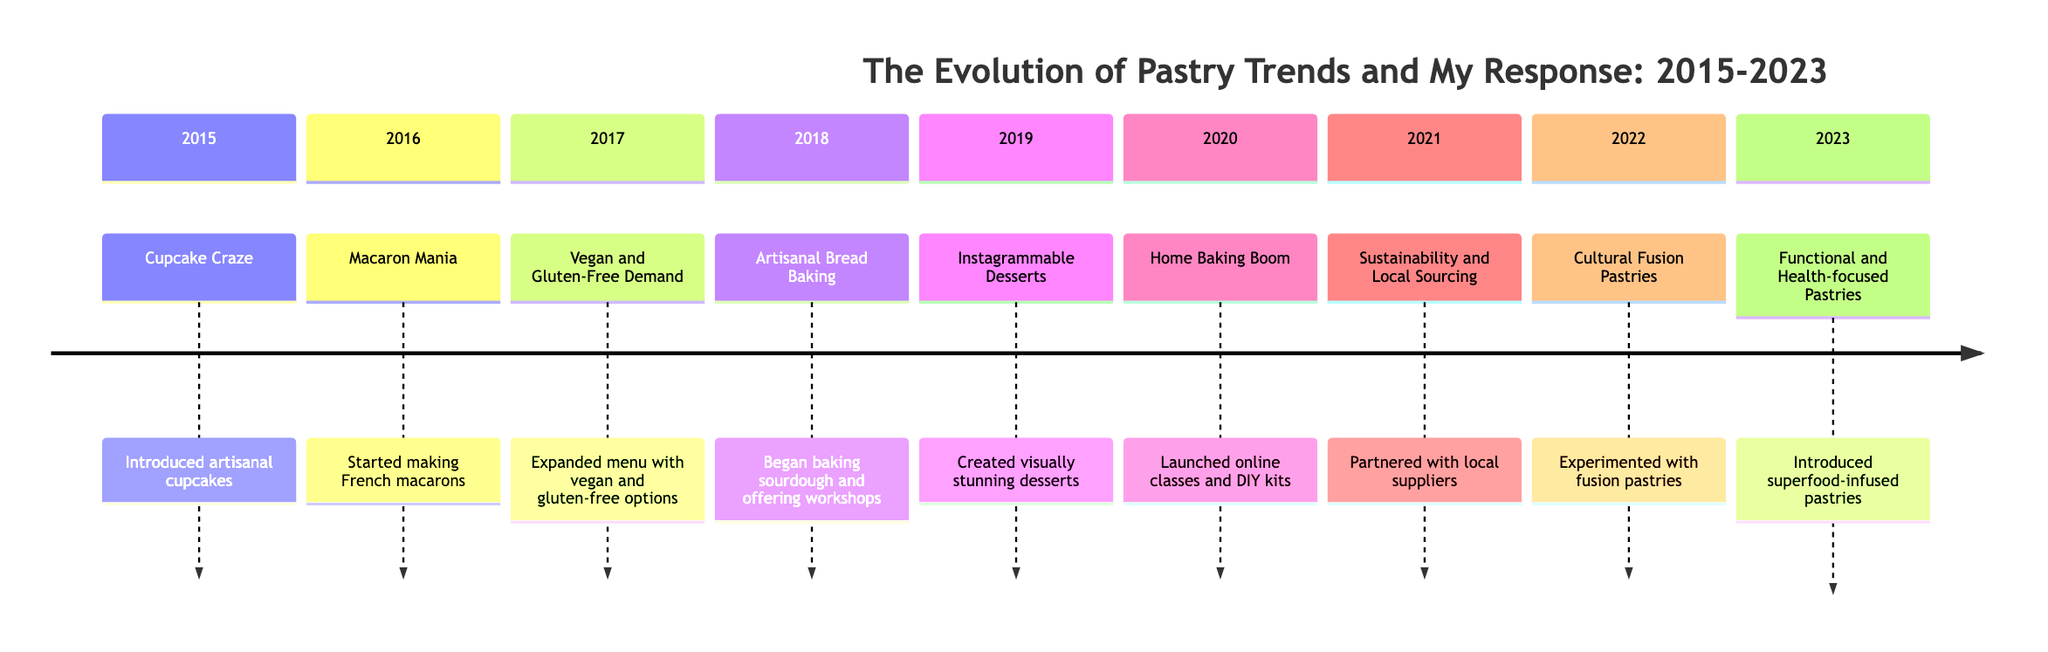What pastry trend was introduced in 2015? The diagram states that the trend introduced in 2015 is "Cupcake Craze," which can be found under the 2015 section.
Answer: Cupcake Craze What unique flavor was added to the cupcakes in 2015? The response under 2015 mentions "lavender honey" as one of the unique flavors introduced with the artisanal cupcakes during the Cupcake Craze.
Answer: Lavender honey How many trends were introduced between 2015 and 2023? By counting each year's trend listed from 2015 to 2023 in the timeline, we find a total of 9 distinct trends.
Answer: 9 What was the trend for the year 2020? The trend listed in the year 2020 is "Home Baking Boom," which is clearly stated in the corresponding section of the timeline.
Answer: Home Baking Boom Which year saw the introduction of fusion pastries? According to the timeline, the year 2022 is when "Cultural Fusion Pastries" were experimented with, as indicated in that year’s section.
Answer: 2022 What is the final trend listed for 2023? The last trend mentioned in the timeline is "Functional and Health-focused Pastries," as shown in the section for the year 2023.
Answer: Functional and Health-focused Pastries Which trend focuses on sustainability? The trend that focuses on sustainability is listed for the year 2021, under "Sustainability and Local Sourcing," as depicted in the corresponding section.
Answer: Sustainability and Local Sourcing What type of pastries were created for social media appeal in 2019? The timeline highlights "Instagrammable Desserts" as the type of pastries created in 2019 to attract social media attention.
Answer: Instagrammable Desserts List one of the exotic flavors introduced for macarons in 2016. The response for the year 2016 mentions "passion fruit" as one of the exotic flavors added to the French macarons.
Answer: Passion fruit 